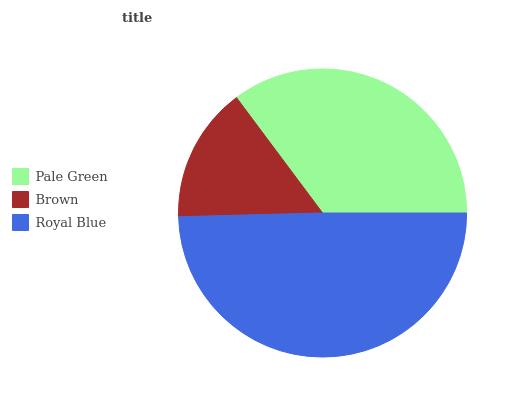Is Brown the minimum?
Answer yes or no. Yes. Is Royal Blue the maximum?
Answer yes or no. Yes. Is Royal Blue the minimum?
Answer yes or no. No. Is Brown the maximum?
Answer yes or no. No. Is Royal Blue greater than Brown?
Answer yes or no. Yes. Is Brown less than Royal Blue?
Answer yes or no. Yes. Is Brown greater than Royal Blue?
Answer yes or no. No. Is Royal Blue less than Brown?
Answer yes or no. No. Is Pale Green the high median?
Answer yes or no. Yes. Is Pale Green the low median?
Answer yes or no. Yes. Is Royal Blue the high median?
Answer yes or no. No. Is Brown the low median?
Answer yes or no. No. 